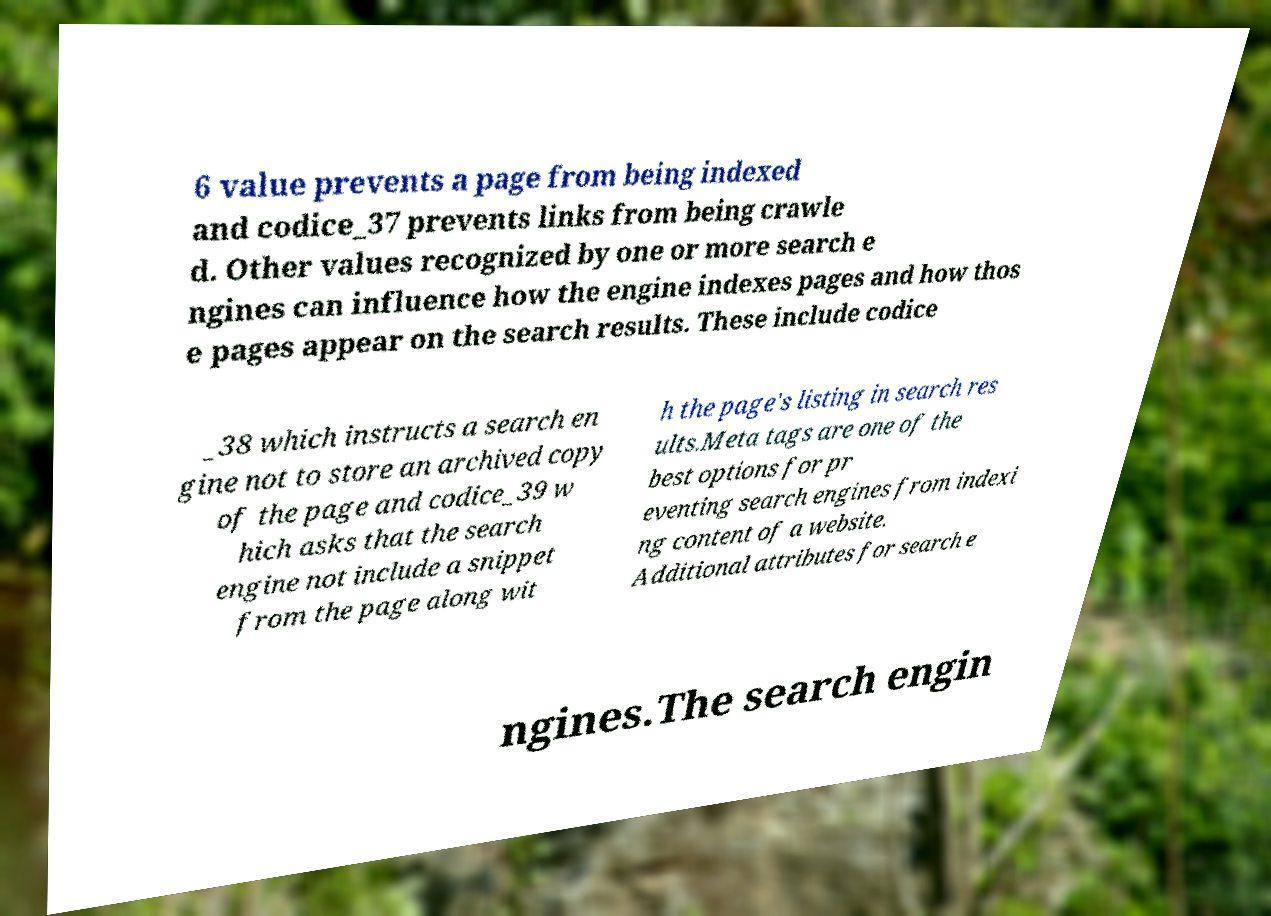Could you extract and type out the text from this image? 6 value prevents a page from being indexed and codice_37 prevents links from being crawle d. Other values recognized by one or more search e ngines can influence how the engine indexes pages and how thos e pages appear on the search results. These include codice _38 which instructs a search en gine not to store an archived copy of the page and codice_39 w hich asks that the search engine not include a snippet from the page along wit h the page's listing in search res ults.Meta tags are one of the best options for pr eventing search engines from indexi ng content of a website. Additional attributes for search e ngines.The search engin 